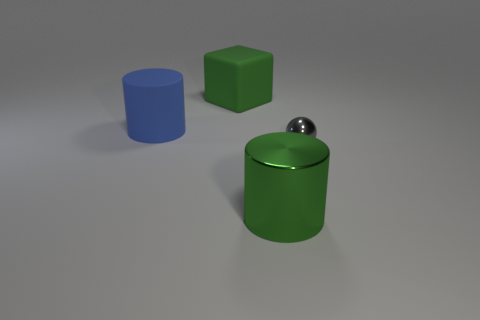Add 1 matte objects. How many objects exist? 5 Subtract all blocks. How many objects are left? 3 Add 2 cyan rubber balls. How many cyan rubber balls exist? 2 Subtract 0 gray cylinders. How many objects are left? 4 Subtract all small yellow matte blocks. Subtract all green blocks. How many objects are left? 3 Add 3 large blue objects. How many large blue objects are left? 4 